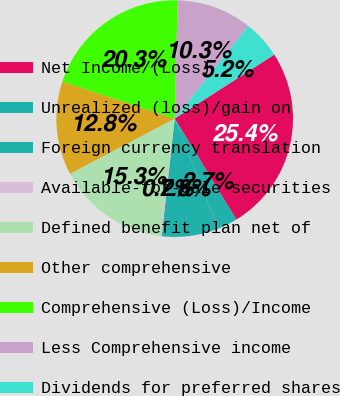<chart> <loc_0><loc_0><loc_500><loc_500><pie_chart><fcel>Net Income/(Loss)<fcel>Unrealized (loss)/gain on<fcel>Foreign currency translation<fcel>Available-for-sale securities<fcel>Defined benefit plan net of<fcel>Other comprehensive<fcel>Comprehensive (Loss)/Income<fcel>Less Comprehensive income<fcel>Dividends for preferred shares<nl><fcel>25.36%<fcel>2.73%<fcel>7.76%<fcel>0.22%<fcel>15.3%<fcel>12.79%<fcel>20.33%<fcel>10.27%<fcel>5.24%<nl></chart> 